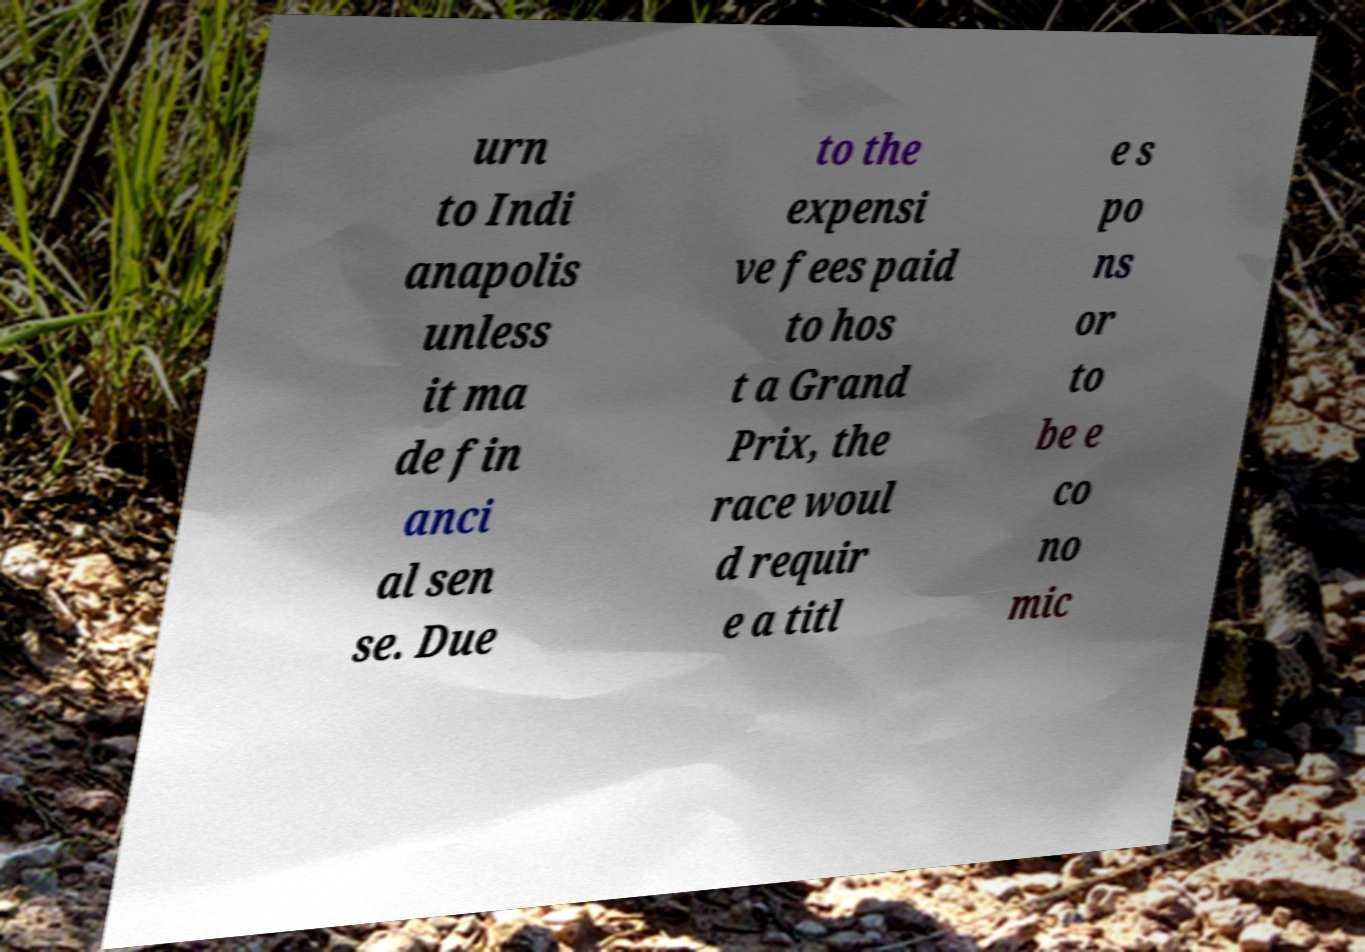For documentation purposes, I need the text within this image transcribed. Could you provide that? urn to Indi anapolis unless it ma de fin anci al sen se. Due to the expensi ve fees paid to hos t a Grand Prix, the race woul d requir e a titl e s po ns or to be e co no mic 